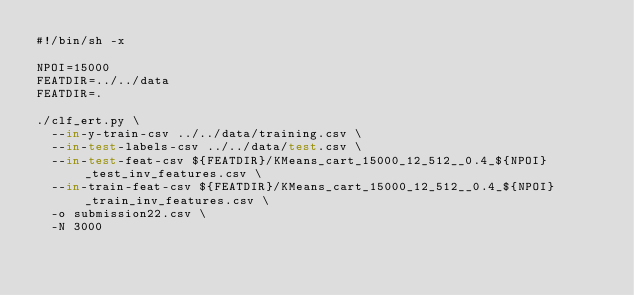<code> <loc_0><loc_0><loc_500><loc_500><_Bash_>#!/bin/sh -x

NPOI=15000
FEATDIR=../../data
FEATDIR=.

./clf_ert.py \
  --in-y-train-csv ../../data/training.csv \
  --in-test-labels-csv ../../data/test.csv \
  --in-test-feat-csv ${FEATDIR}/KMeans_cart_15000_12_512__0.4_${NPOI}_test_inv_features.csv \
  --in-train-feat-csv ${FEATDIR}/KMeans_cart_15000_12_512__0.4_${NPOI}_train_inv_features.csv \
  -o submission22.csv \
  -N 3000
</code> 